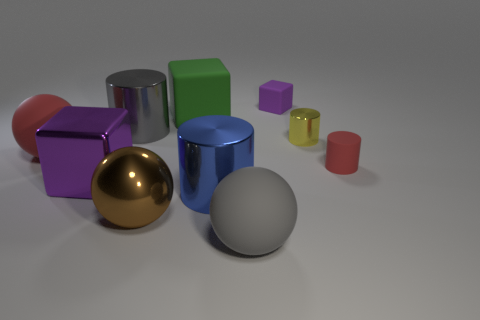Subtract all cubes. How many objects are left? 7 Add 4 big purple shiny balls. How many big purple shiny balls exist? 4 Subtract 0 brown cylinders. How many objects are left? 10 Subtract all big red matte spheres. Subtract all big matte spheres. How many objects are left? 7 Add 7 big shiny cylinders. How many big shiny cylinders are left? 9 